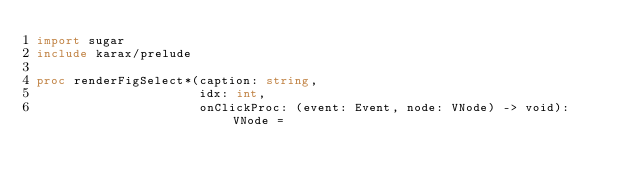<code> <loc_0><loc_0><loc_500><loc_500><_Nim_>import sugar
include karax/prelude

proc renderFigSelect*(caption: string,
                      idx: int,
                      onClickProc: (event: Event, node: VNode) -> void): VNode =</code> 